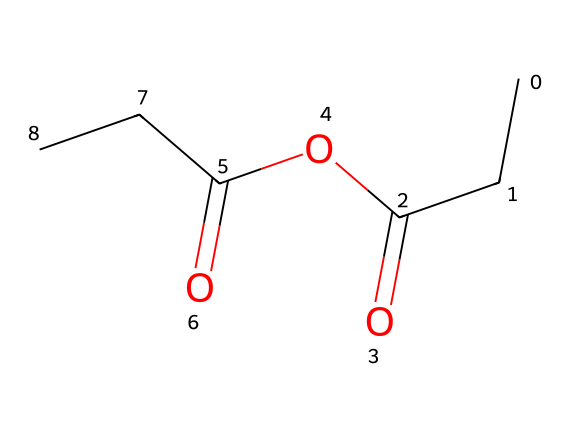What is the molecular formula of propionic anhydride? By analyzing the SMILES representation, we can identify the atoms present: there are 5 carbon (C) atoms, 6 hydrogen (H) atoms, and 3 oxygen (O) atoms, leading to the molecular formula C5H6O3.
Answer: C5H6O3 How many carbon atoms are in propionic anhydride? In the SMILES representation, each "C" represents a carbon atom. Counting these gives us a total of 5 carbon atoms.
Answer: 5 Is propionic anhydride symmetric or asymmetric? The chemical structure has different groups on either side of the anhydride bond, indicating that it is asymmetric.
Answer: asymmetric What type of functional groups are present in propionic anhydride? The SMILES contains an anhydride functional group (due to the OC(=O) part), and also displays carbonyl (C=O) and alkyl (C-C) functionalities, which are indicative of an acid anhydride.
Answer: anhydride How many oxygen atoms are present in propionic anhydride? The structure indicates the presence of three oxygen atoms, shown in the SMILES as O and C(=O).
Answer: 3 What is the primary use of propionic anhydride in cleaning solutions? Propionic anhydride is often used as a solvent in cleaning solutions due to its ability to dissolve grease and grime.
Answer: solvent 